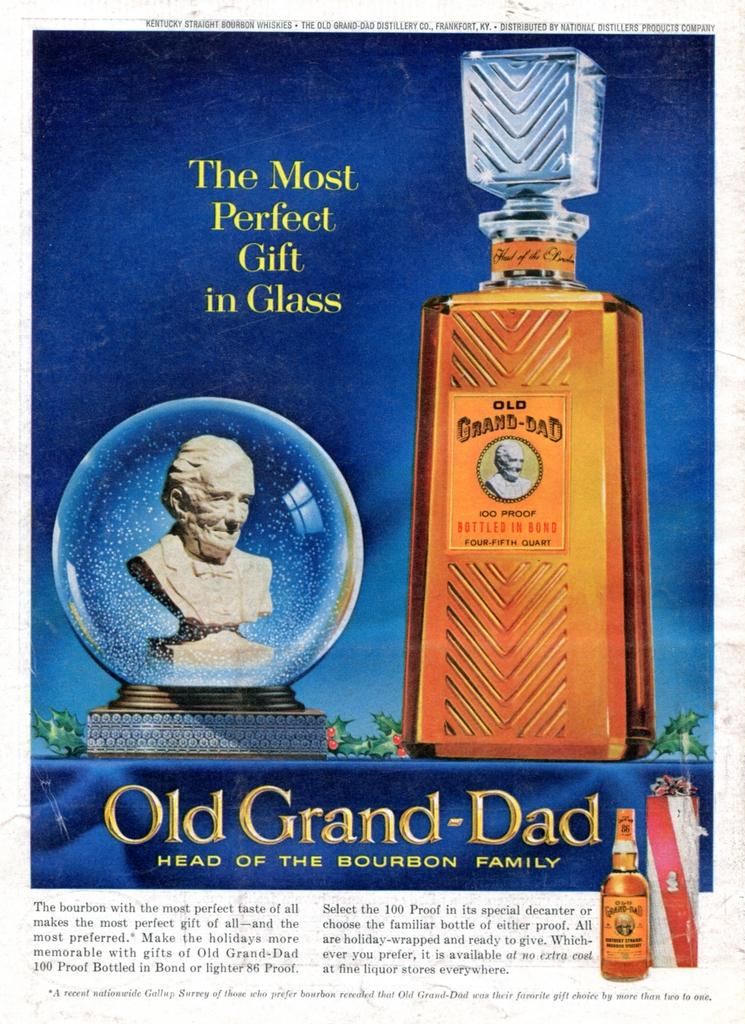<image>
Relay a brief, clear account of the picture shown. An advertisement for Old Grand-Dad Bourbon states that it is "The Most Perfect Gift in Glass". 